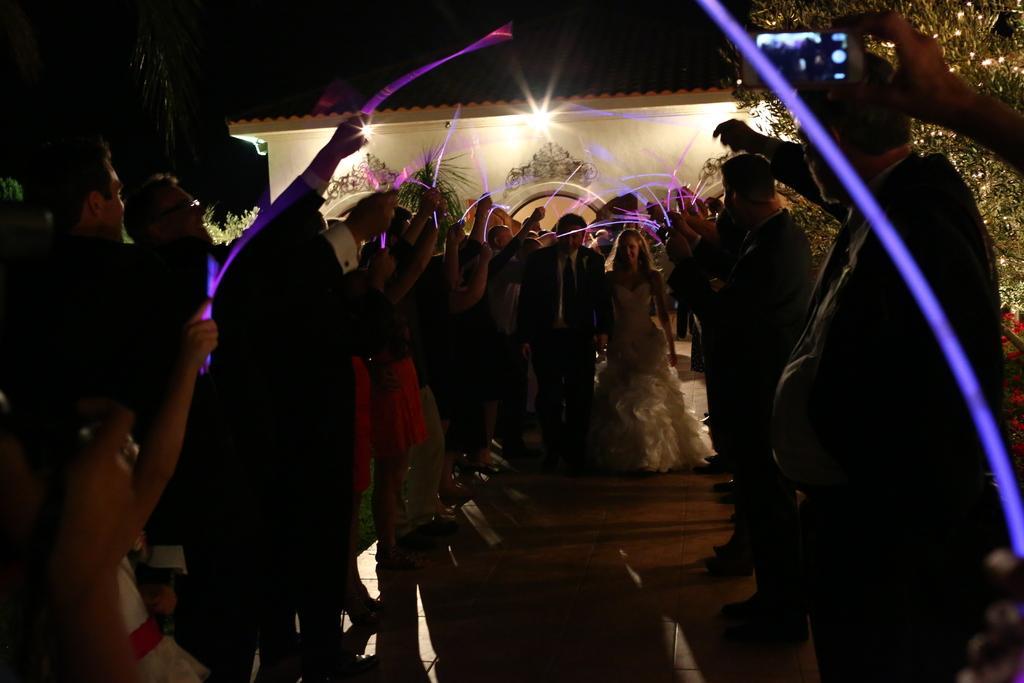In one or two sentences, can you explain what this image depicts? There are groups of people standing. Among them few people are holding the lights in their hands. This looks like a building. These are the trees. On the right side of the image, I can see a person's hand holding a mobile phone and clicking pictures. 